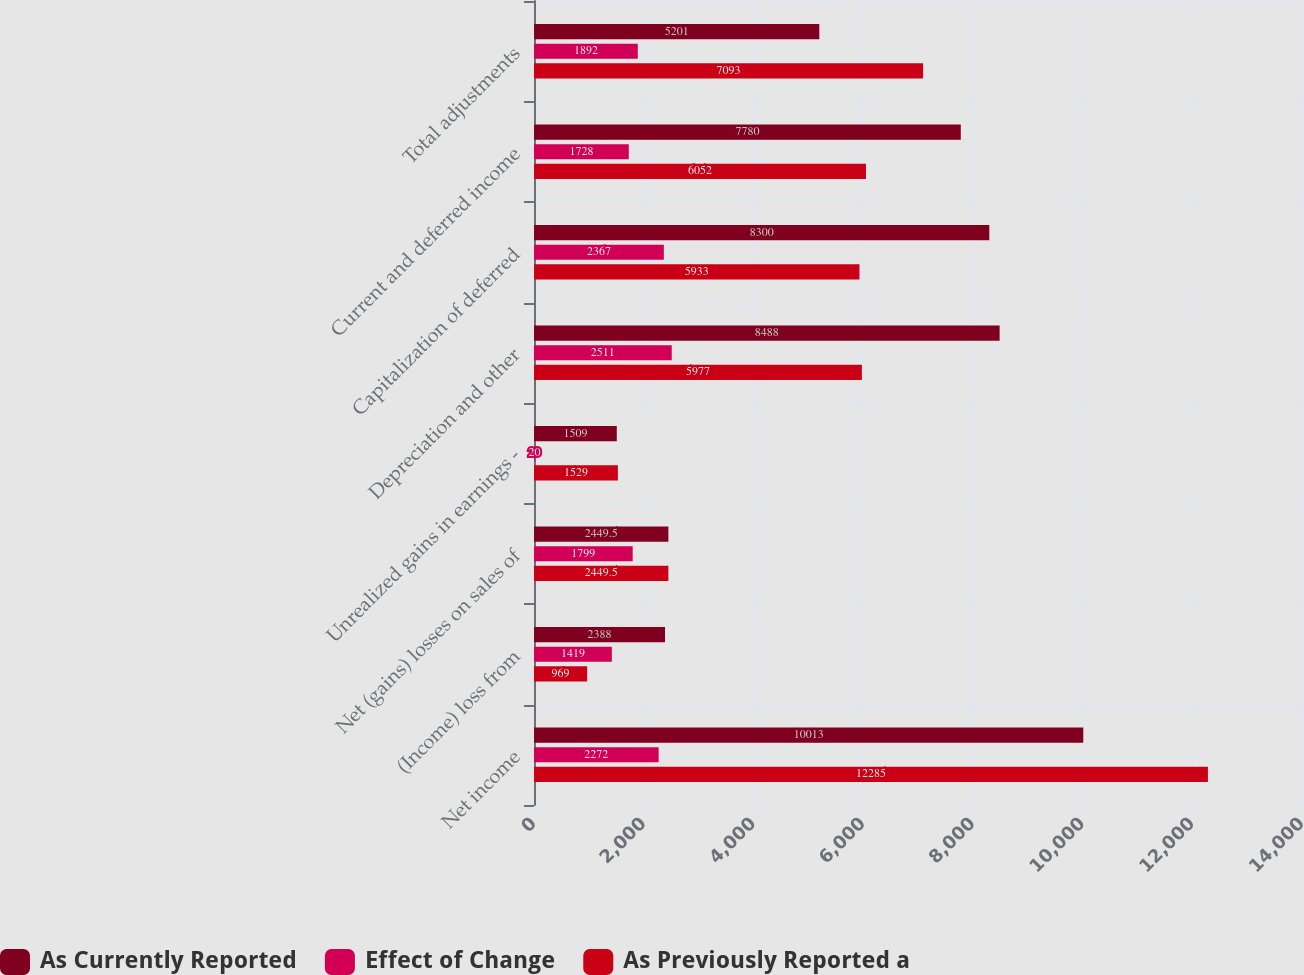<chart> <loc_0><loc_0><loc_500><loc_500><stacked_bar_chart><ecel><fcel>Net income<fcel>(Income) loss from<fcel>Net (gains) losses on sales of<fcel>Unrealized gains in earnings -<fcel>Depreciation and other<fcel>Capitalization of deferred<fcel>Current and deferred income<fcel>Total adjustments<nl><fcel>As Currently Reported<fcel>10013<fcel>2388<fcel>2449.5<fcel>1509<fcel>8488<fcel>8300<fcel>7780<fcel>5201<nl><fcel>Effect of Change<fcel>2272<fcel>1419<fcel>1799<fcel>20<fcel>2511<fcel>2367<fcel>1728<fcel>1892<nl><fcel>As Previously Reported a<fcel>12285<fcel>969<fcel>2449.5<fcel>1529<fcel>5977<fcel>5933<fcel>6052<fcel>7093<nl></chart> 